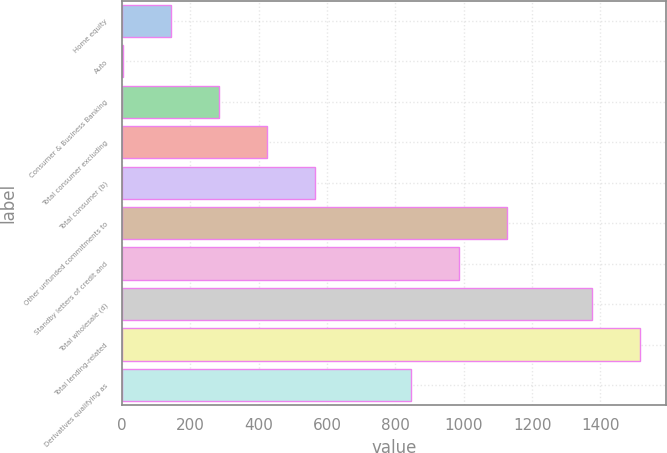<chart> <loc_0><loc_0><loc_500><loc_500><bar_chart><fcel>Home equity<fcel>Auto<fcel>Consumer & Business Banking<fcel>Total consumer excluding<fcel>Total consumer (b)<fcel>Other unfunded commitments to<fcel>Standby letters of credit and<fcel>Total wholesale (d)<fcel>Total lending-related<fcel>Derivatives qualifying as<nl><fcel>142.7<fcel>2<fcel>283.4<fcel>424.1<fcel>564.8<fcel>1127.6<fcel>986.9<fcel>1376<fcel>1516.7<fcel>846.2<nl></chart> 